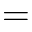<formula> <loc_0><loc_0><loc_500><loc_500>=</formula> 